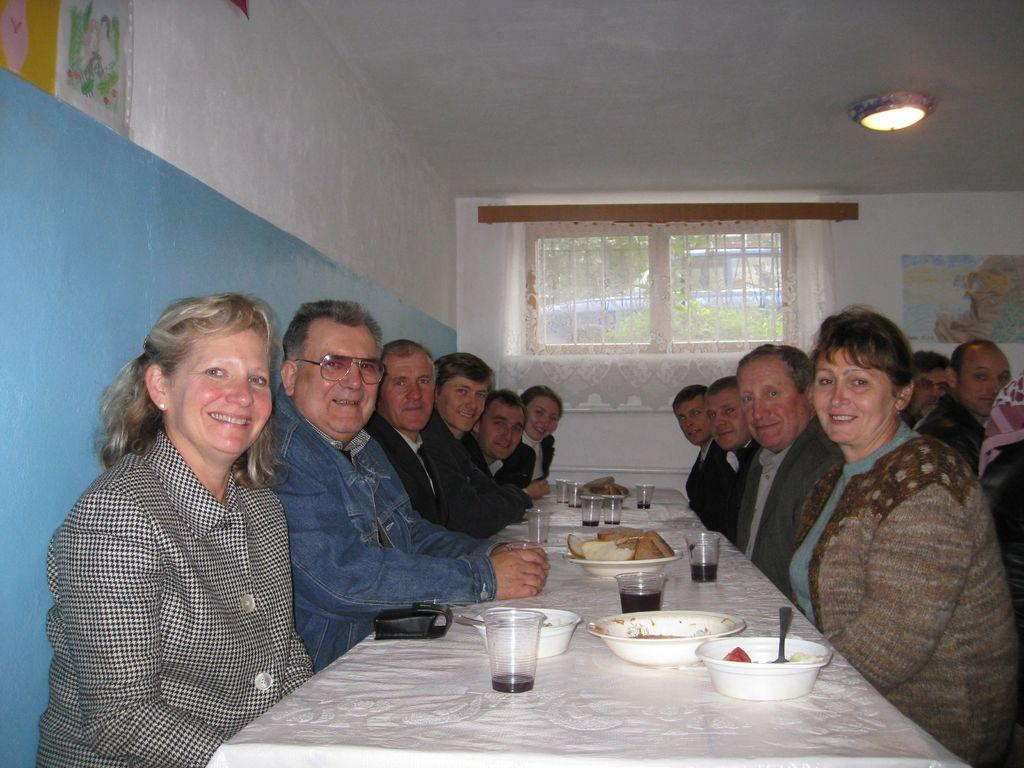How many people are in the image? There is a group of people in the image. What are the people doing in the image? The people are sitting on chairs. Where are the chairs located in relation to the table? The chairs are in front of a table. What can be seen on the table in the image? There are glasses and other objects on the table. What type of neck can be seen on the table in the image? There is no neck present on the table in the image. How does the agreement between the people affect the objects on the table? There is no mention of an agreement between the people in the image, and therefore its effect on the objects on the table cannot be determined. 